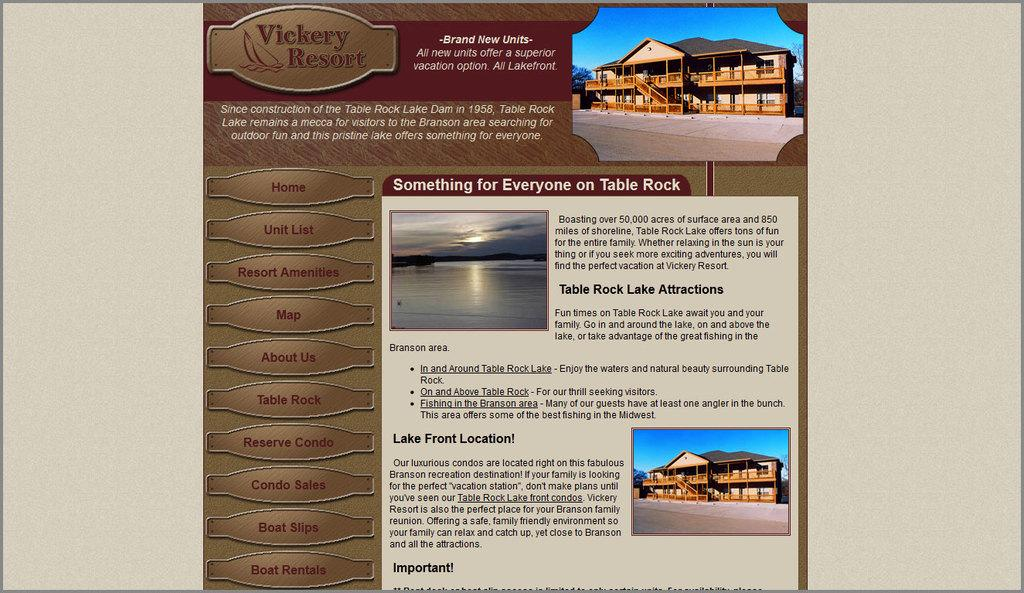Provide a one-sentence caption for the provided image. a page on a website that says Lake Front Location. 